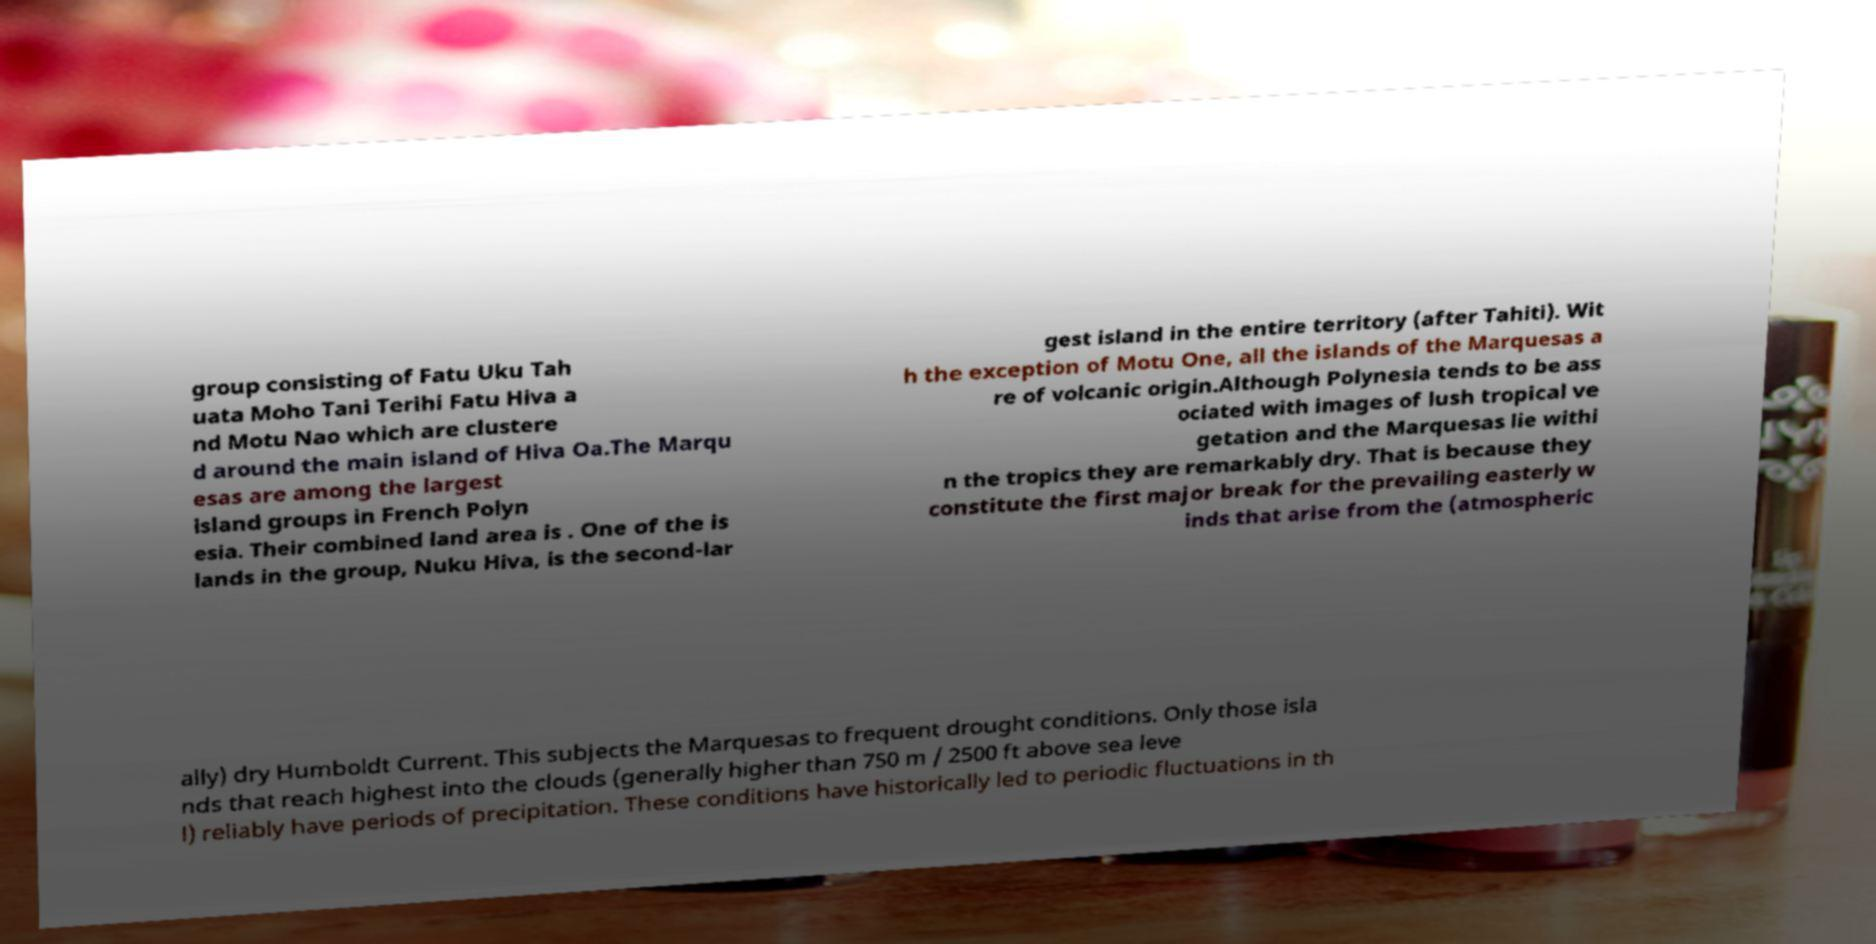What messages or text are displayed in this image? I need them in a readable, typed format. group consisting of Fatu Uku Tah uata Moho Tani Terihi Fatu Hiva a nd Motu Nao which are clustere d around the main island of Hiva Oa.The Marqu esas are among the largest island groups in French Polyn esia. Their combined land area is . One of the is lands in the group, Nuku Hiva, is the second-lar gest island in the entire territory (after Tahiti). Wit h the exception of Motu One, all the islands of the Marquesas a re of volcanic origin.Although Polynesia tends to be ass ociated with images of lush tropical ve getation and the Marquesas lie withi n the tropics they are remarkably dry. That is because they constitute the first major break for the prevailing easterly w inds that arise from the (atmospheric ally) dry Humboldt Current. This subjects the Marquesas to frequent drought conditions. Only those isla nds that reach highest into the clouds (generally higher than 750 m / 2500 ft above sea leve l) reliably have periods of precipitation. These conditions have historically led to periodic fluctuations in th 